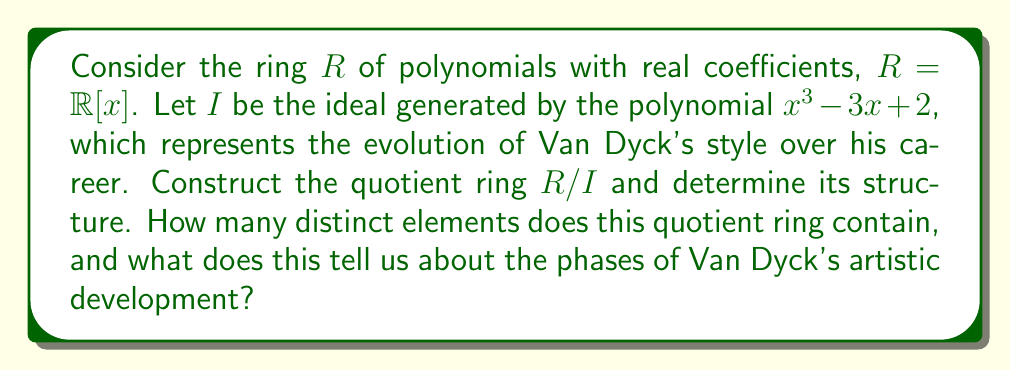Could you help me with this problem? To solve this problem, we'll follow these steps:

1) First, we need to understand what the quotient ring $R/I$ represents. In this context, it can be thought of as the set of all possible "styles" in Van Dyck's artistic career, modulo the changes represented by the polynomial $x^3 - 3x + 2$.

2) The key to solving this problem is to recognize that $x^3 - 3x + 2$ is a cubic polynomial, and it's irreducible over $\mathbb{R}$. We can verify this by noting that it has no real roots (you can check this using the discriminant or by plotting).

3) Because $x^3 - 3x + 2$ is irreducible over $\mathbb{R}$, the ideal $I$ it generates is maximal in $R$.

4) When we quotient $R$ by a maximal ideal, the result is always a field. In this case, we're getting a field extension of $\mathbb{R}$ of degree 3.

5) The elements of $R/I$ can be represented uniquely by polynomials of degree less than 3. In other words, every element of $R/I$ can be written uniquely in the form $ax^2 + bx + c$, where $a, b, c \in \mathbb{R}$.

6) This means that $R/I$ is isomorphic to $\mathbb{R}^3$ as a vector space over $\mathbb{R}$. It has uncountably many elements, corresponding to all possible triples $(a,b,c)$ of real numbers.

7) In the context of Van Dyck's artistic development, we can interpret this as follows: His style can be described by three independent real parameters, potentially representing aspects like color palette, brushwork technique, and compositional approach. The quotient ring structure suggests that these aspects evolved continuously and interdependently over his career, with the polynomial $x^3 - 3x + 2$ capturing the overall trajectory of this evolution.
Answer: The quotient ring $R/I$ contains uncountably many elements, as it is isomorphic to $\mathbb{R}^3$ as a vector space over $\mathbb{R}$. This suggests that Van Dyck's artistic development can be modeled as a continuous evolution in a three-dimensional space of stylistic parameters. 